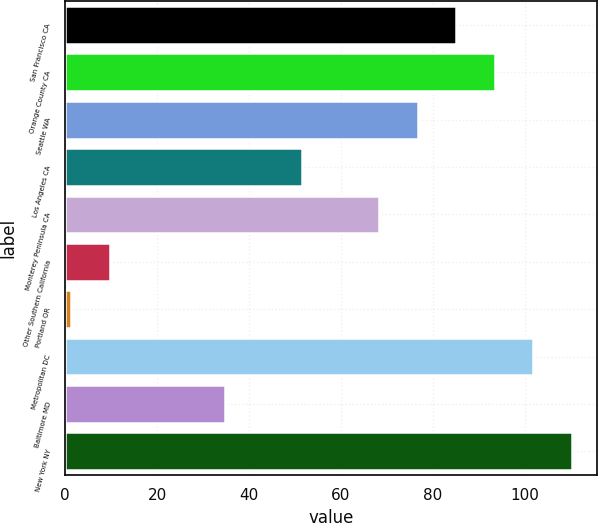Convert chart. <chart><loc_0><loc_0><loc_500><loc_500><bar_chart><fcel>San Francisco CA<fcel>Orange County CA<fcel>Seattle WA<fcel>Los Angeles CA<fcel>Monterey Peninsula CA<fcel>Other Southern California<fcel>Portland OR<fcel>Metropolitan DC<fcel>Baltimore MD<fcel>New York NY<nl><fcel>85.1<fcel>93.48<fcel>76.72<fcel>51.58<fcel>68.34<fcel>9.68<fcel>1.3<fcel>101.86<fcel>34.82<fcel>110.24<nl></chart> 